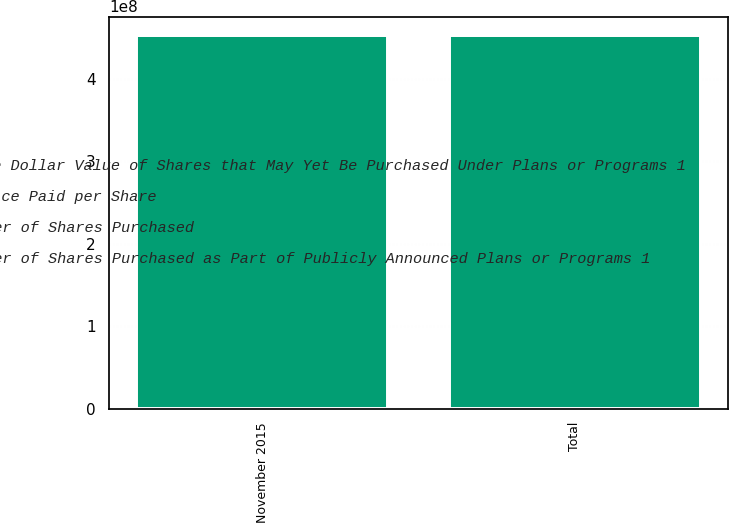Convert chart to OTSL. <chart><loc_0><loc_0><loc_500><loc_500><stacked_bar_chart><ecel><fcel>November 2015<fcel>Total<nl><fcel>Total Number of Shares Purchased as Part of Publicly Announced Plans or Programs 1<fcel>1.41496e+06<fcel>1.41496e+06<nl><fcel>Average Price Paid per Share<fcel>106.01<fcel>106.01<nl><fcel>Approximate Dollar Value of Shares that May Yet Be Purchased Under Plans or Programs 1<fcel>1.41496e+06<fcel>1.41496e+06<nl><fcel>Total Number of Shares Purchased<fcel>4.49535e+08<fcel>4.49535e+08<nl></chart> 